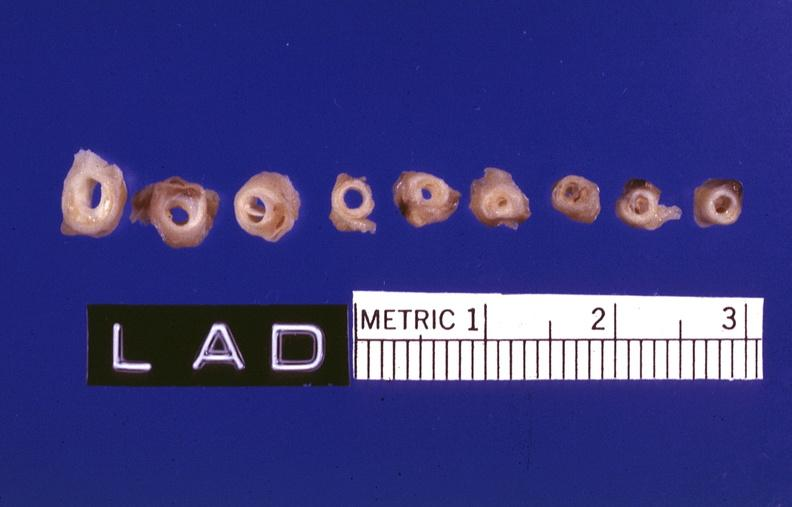s vasculature present?
Answer the question using a single word or phrase. Yes 